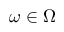Convert formula to latex. <formula><loc_0><loc_0><loc_500><loc_500>\omega \in \Omega</formula> 